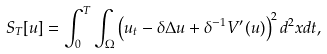Convert formula to latex. <formula><loc_0><loc_0><loc_500><loc_500>S _ { T } [ u ] = \int _ { 0 } ^ { T } \int _ { \Omega } \left ( u _ { t } - \delta \Delta u + \delta ^ { - 1 } V ^ { \prime } ( u ) \right ) ^ { 2 } d ^ { 2 } x d t ,</formula> 